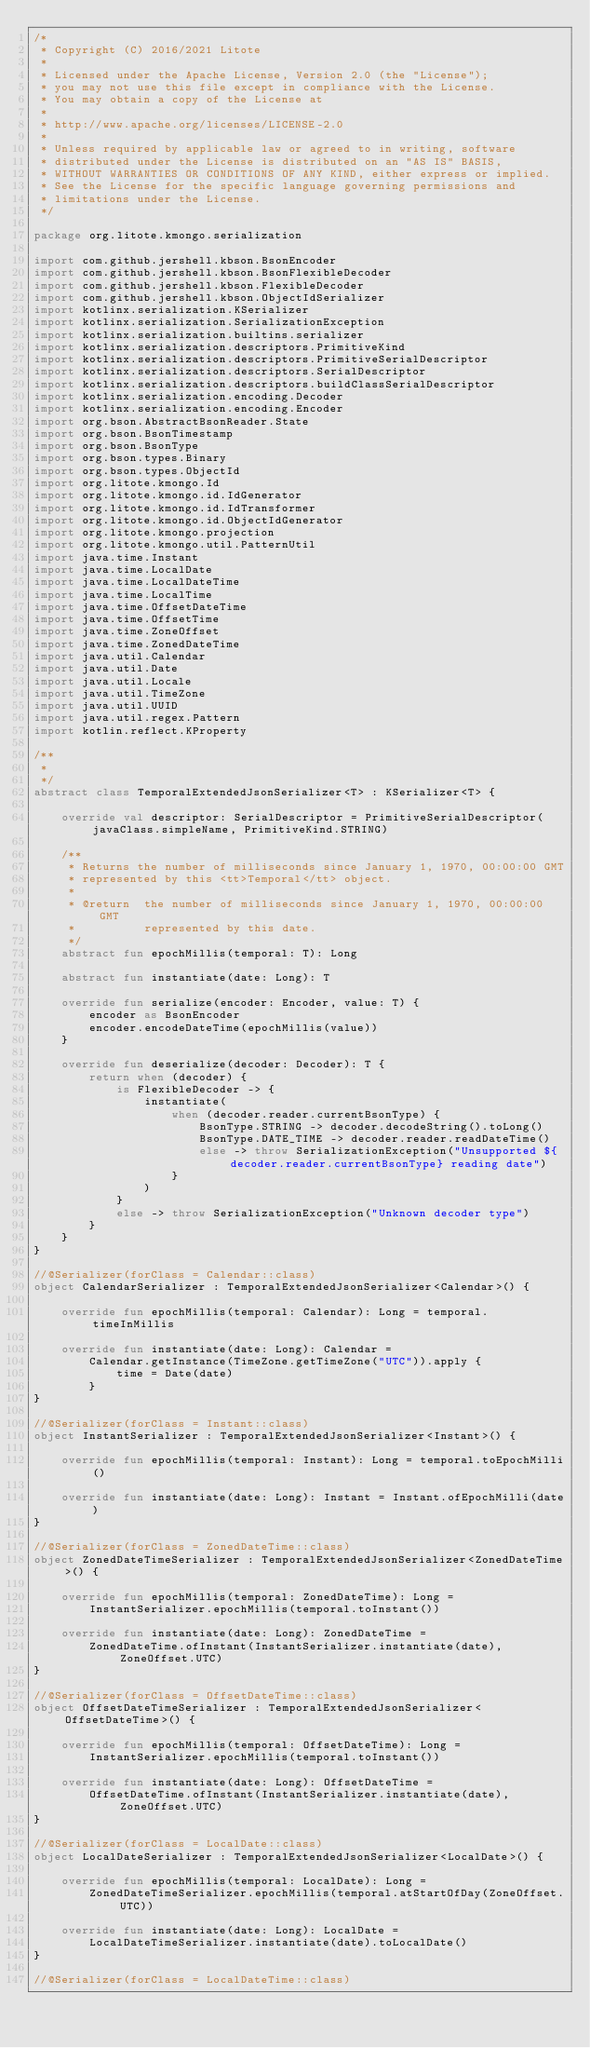<code> <loc_0><loc_0><loc_500><loc_500><_Kotlin_>/*
 * Copyright (C) 2016/2021 Litote
 *
 * Licensed under the Apache License, Version 2.0 (the "License");
 * you may not use this file except in compliance with the License.
 * You may obtain a copy of the License at
 *
 * http://www.apache.org/licenses/LICENSE-2.0
 *
 * Unless required by applicable law or agreed to in writing, software
 * distributed under the License is distributed on an "AS IS" BASIS,
 * WITHOUT WARRANTIES OR CONDITIONS OF ANY KIND, either express or implied.
 * See the License for the specific language governing permissions and
 * limitations under the License.
 */

package org.litote.kmongo.serialization

import com.github.jershell.kbson.BsonEncoder
import com.github.jershell.kbson.BsonFlexibleDecoder
import com.github.jershell.kbson.FlexibleDecoder
import com.github.jershell.kbson.ObjectIdSerializer
import kotlinx.serialization.KSerializer
import kotlinx.serialization.SerializationException
import kotlinx.serialization.builtins.serializer
import kotlinx.serialization.descriptors.PrimitiveKind
import kotlinx.serialization.descriptors.PrimitiveSerialDescriptor
import kotlinx.serialization.descriptors.SerialDescriptor
import kotlinx.serialization.descriptors.buildClassSerialDescriptor
import kotlinx.serialization.encoding.Decoder
import kotlinx.serialization.encoding.Encoder
import org.bson.AbstractBsonReader.State
import org.bson.BsonTimestamp
import org.bson.BsonType
import org.bson.types.Binary
import org.bson.types.ObjectId
import org.litote.kmongo.Id
import org.litote.kmongo.id.IdGenerator
import org.litote.kmongo.id.IdTransformer
import org.litote.kmongo.id.ObjectIdGenerator
import org.litote.kmongo.projection
import org.litote.kmongo.util.PatternUtil
import java.time.Instant
import java.time.LocalDate
import java.time.LocalDateTime
import java.time.LocalTime
import java.time.OffsetDateTime
import java.time.OffsetTime
import java.time.ZoneOffset
import java.time.ZonedDateTime
import java.util.Calendar
import java.util.Date
import java.util.Locale
import java.util.TimeZone
import java.util.UUID
import java.util.regex.Pattern
import kotlin.reflect.KProperty

/**
 *
 */
abstract class TemporalExtendedJsonSerializer<T> : KSerializer<T> {

    override val descriptor: SerialDescriptor = PrimitiveSerialDescriptor(javaClass.simpleName, PrimitiveKind.STRING)

    /**
     * Returns the number of milliseconds since January 1, 1970, 00:00:00 GMT
     * represented by this <tt>Temporal</tt> object.
     *
     * @return  the number of milliseconds since January 1, 1970, 00:00:00 GMT
     *          represented by this date.
     */
    abstract fun epochMillis(temporal: T): Long

    abstract fun instantiate(date: Long): T

    override fun serialize(encoder: Encoder, value: T) {
        encoder as BsonEncoder
        encoder.encodeDateTime(epochMillis(value))
    }

    override fun deserialize(decoder: Decoder): T {
        return when (decoder) {
            is FlexibleDecoder -> {
                instantiate(
                    when (decoder.reader.currentBsonType) {
                        BsonType.STRING -> decoder.decodeString().toLong()
                        BsonType.DATE_TIME -> decoder.reader.readDateTime()
                        else -> throw SerializationException("Unsupported ${decoder.reader.currentBsonType} reading date")
                    }
                )
            }
            else -> throw SerializationException("Unknown decoder type")
        }
    }
}

//@Serializer(forClass = Calendar::class)
object CalendarSerializer : TemporalExtendedJsonSerializer<Calendar>() {

    override fun epochMillis(temporal: Calendar): Long = temporal.timeInMillis

    override fun instantiate(date: Long): Calendar =
        Calendar.getInstance(TimeZone.getTimeZone("UTC")).apply {
            time = Date(date)
        }
}

//@Serializer(forClass = Instant::class)
object InstantSerializer : TemporalExtendedJsonSerializer<Instant>() {

    override fun epochMillis(temporal: Instant): Long = temporal.toEpochMilli()

    override fun instantiate(date: Long): Instant = Instant.ofEpochMilli(date)
}

//@Serializer(forClass = ZonedDateTime::class)
object ZonedDateTimeSerializer : TemporalExtendedJsonSerializer<ZonedDateTime>() {

    override fun epochMillis(temporal: ZonedDateTime): Long =
        InstantSerializer.epochMillis(temporal.toInstant())

    override fun instantiate(date: Long): ZonedDateTime =
        ZonedDateTime.ofInstant(InstantSerializer.instantiate(date), ZoneOffset.UTC)
}

//@Serializer(forClass = OffsetDateTime::class)
object OffsetDateTimeSerializer : TemporalExtendedJsonSerializer<OffsetDateTime>() {

    override fun epochMillis(temporal: OffsetDateTime): Long =
        InstantSerializer.epochMillis(temporal.toInstant())

    override fun instantiate(date: Long): OffsetDateTime =
        OffsetDateTime.ofInstant(InstantSerializer.instantiate(date), ZoneOffset.UTC)
}

//@Serializer(forClass = LocalDate::class)
object LocalDateSerializer : TemporalExtendedJsonSerializer<LocalDate>() {

    override fun epochMillis(temporal: LocalDate): Long =
        ZonedDateTimeSerializer.epochMillis(temporal.atStartOfDay(ZoneOffset.UTC))

    override fun instantiate(date: Long): LocalDate =
        LocalDateTimeSerializer.instantiate(date).toLocalDate()
}

//@Serializer(forClass = LocalDateTime::class)</code> 